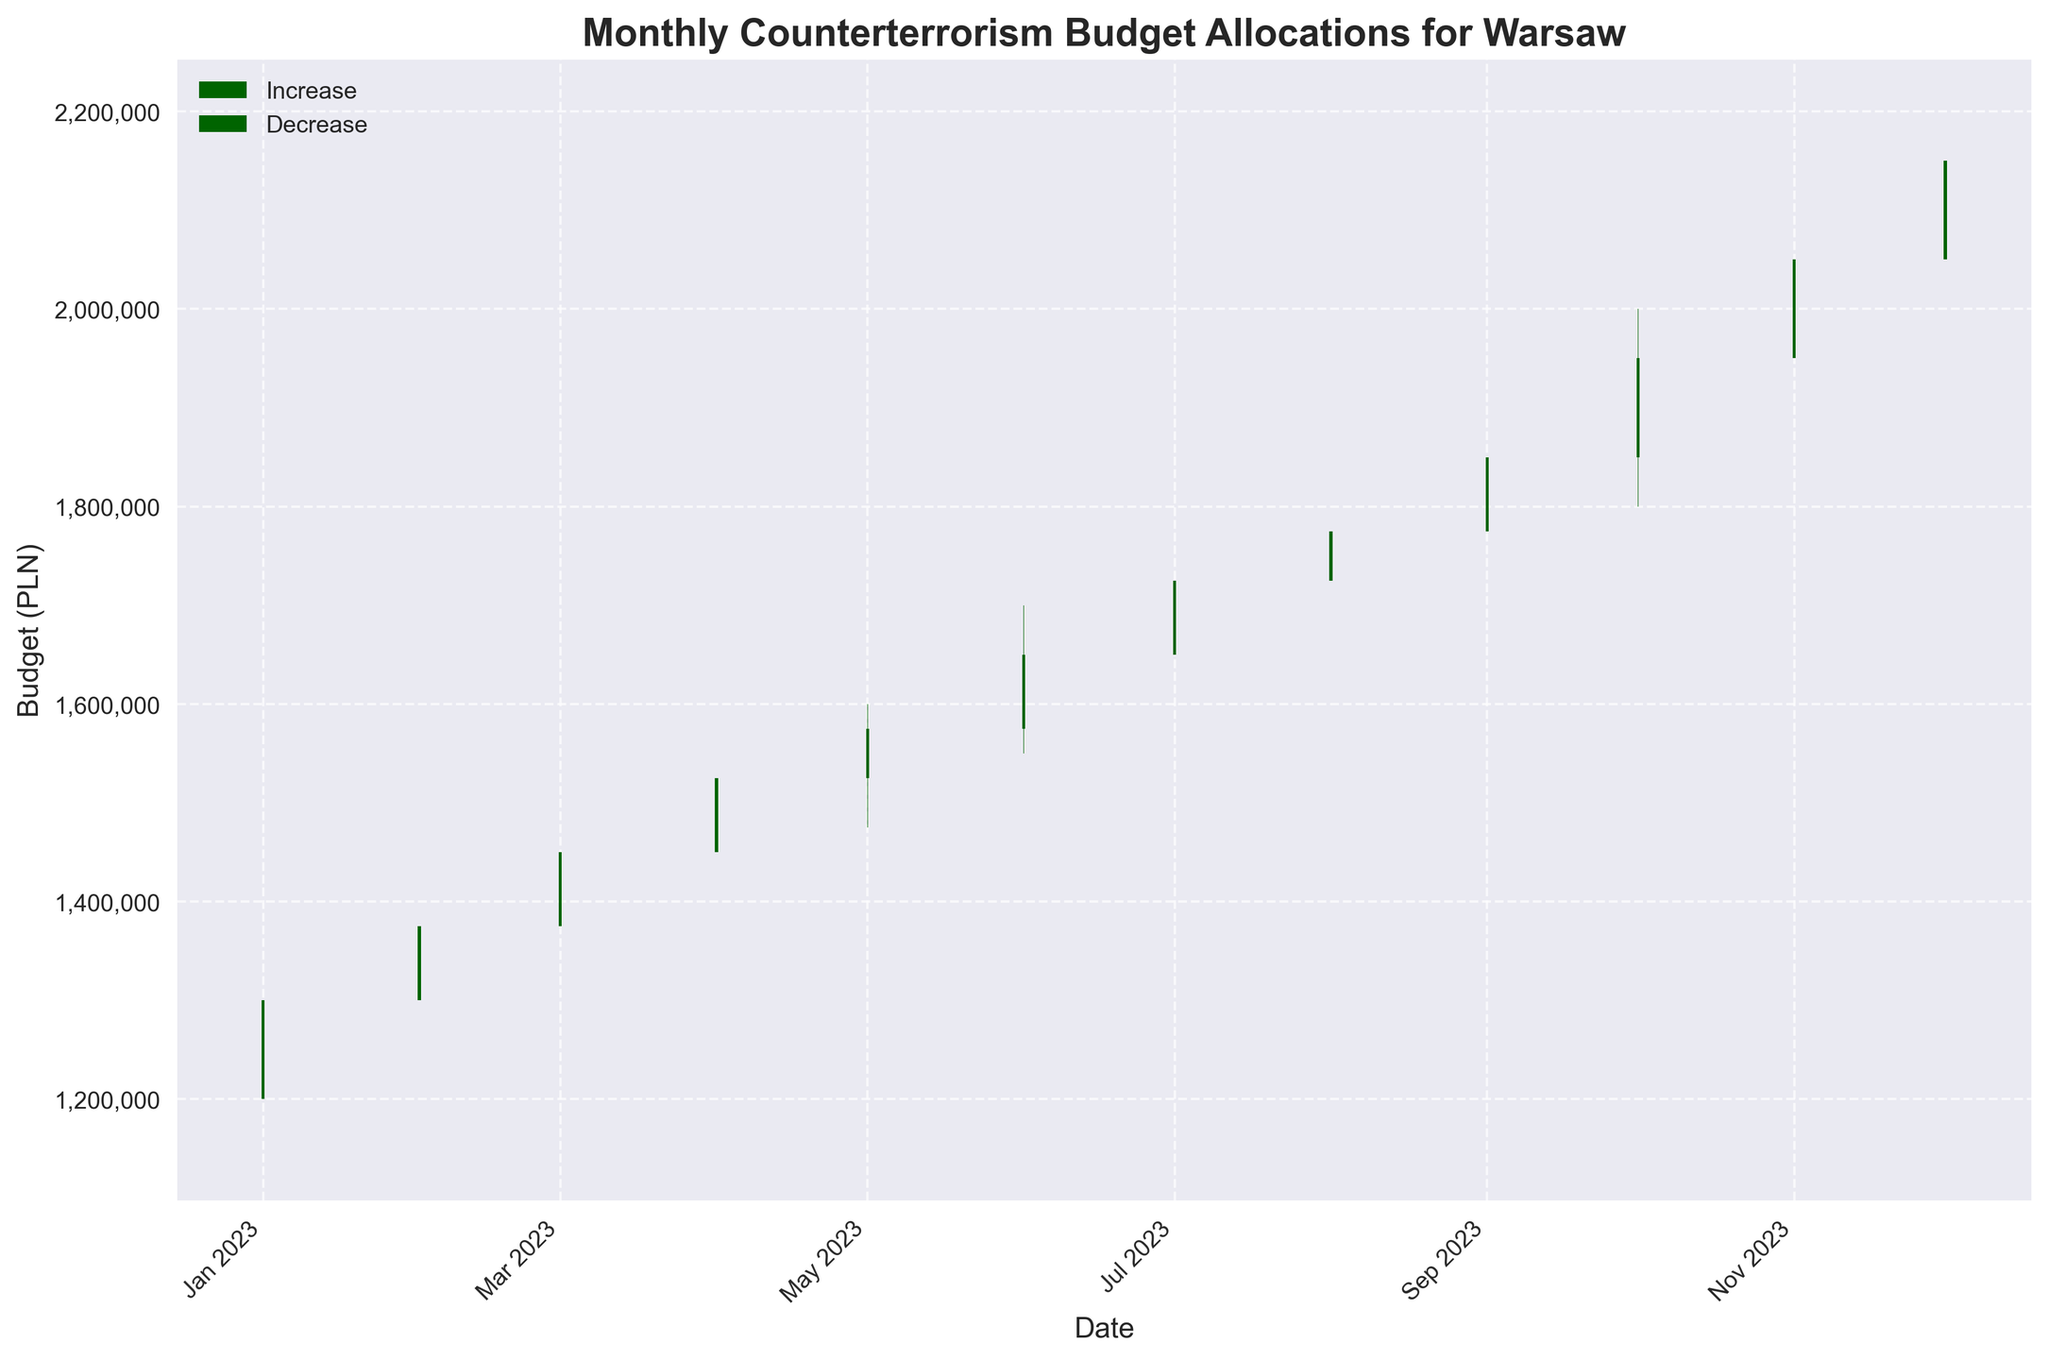What is the title of the plot? The title of the plot is located at the top of the figure and usually summarizes the main subject of the chart. Here, it reads "Monthly Counterterrorism Budget Allocations for Warsaw."
Answer: Monthly Counterterrorism Budget Allocations for Warsaw What are the units on the y-axis? The y-axis typically shows the range of the variable being measured. In this case, it represents the budget in PLN (Polish złoty).
Answer: PLN What is the pattern observed in the budget allocations from January to December? By analyzing the OHLC bars from January to December, we observe an increasing trend in the counterterrorism budget allocation.
Answer: Increasing trend Which month had the highest closing budget allocation? The closing budget is depicted by the top of each bar (the top of the square for increasing months, and the bottom for decreasing months). December has the highest closing budget of 2,150,000 PLN.
Answer: December How does the closing budget in October compare to November? The OHLC chart shows the closing budget for October and November. October's closing budget is 1,950,000 PLN while November's is 2,050,000 PLN, indicating an increase.
Answer: November is higher Compare the lowest and highest points reached throughout the year. Which months do they correspond to? The lowest point on the y-axis corresponds to January's low of 1,150,000 PLN, and the highest point corresponds to December’s high of 2,200,000 PLN.
Answer: January and December What was the closing budget allocation in March? The closing budget for March is represented by the top of the bar for that month, which is 1,450,000 PLN.
Answer: 1,450,000 PLN Which month had the largest difference between its high and low values? By observing each month’s high and low values, September shows the largest difference, ranging from a low of 1,725,000 PLN to a high of 1,900,000 PLN, a difference of 175,000 PLN.
Answer: September What is the predominant color in the bars indicating months with an increase in budget? The bars indicating an increase are colored in dark green.
Answer: Dark green Calculate the average closing budget for the first quarter (January to March). The closing budgets are 1,300,000 PLN for January, 1,375,000 PLN for February, and 1,450,000 PLN for March. (1,300,000 + 1,375,000 + 1,450,000) / 3 = 4,125,000 / 3 = 1,375,000 PLN.
Answer: 1,375,000 PLN 